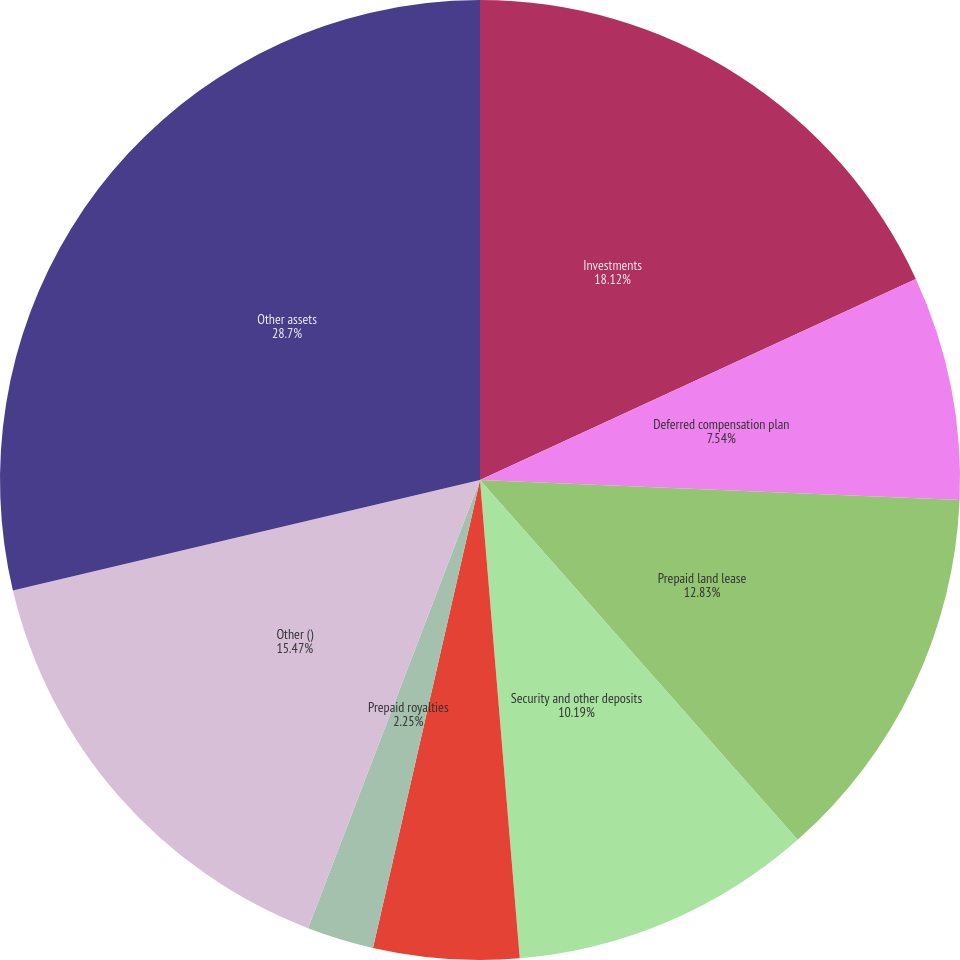Convert chart. <chart><loc_0><loc_0><loc_500><loc_500><pie_chart><fcel>Investments<fcel>Deferred compensation plan<fcel>Prepaid land lease<fcel>Security and other deposits<fcel>Debt issuance costs<fcel>Prepaid royalties<fcel>Other ()<fcel>Other assets<nl><fcel>18.12%<fcel>7.54%<fcel>12.83%<fcel>10.19%<fcel>4.9%<fcel>2.25%<fcel>15.47%<fcel>28.7%<nl></chart> 